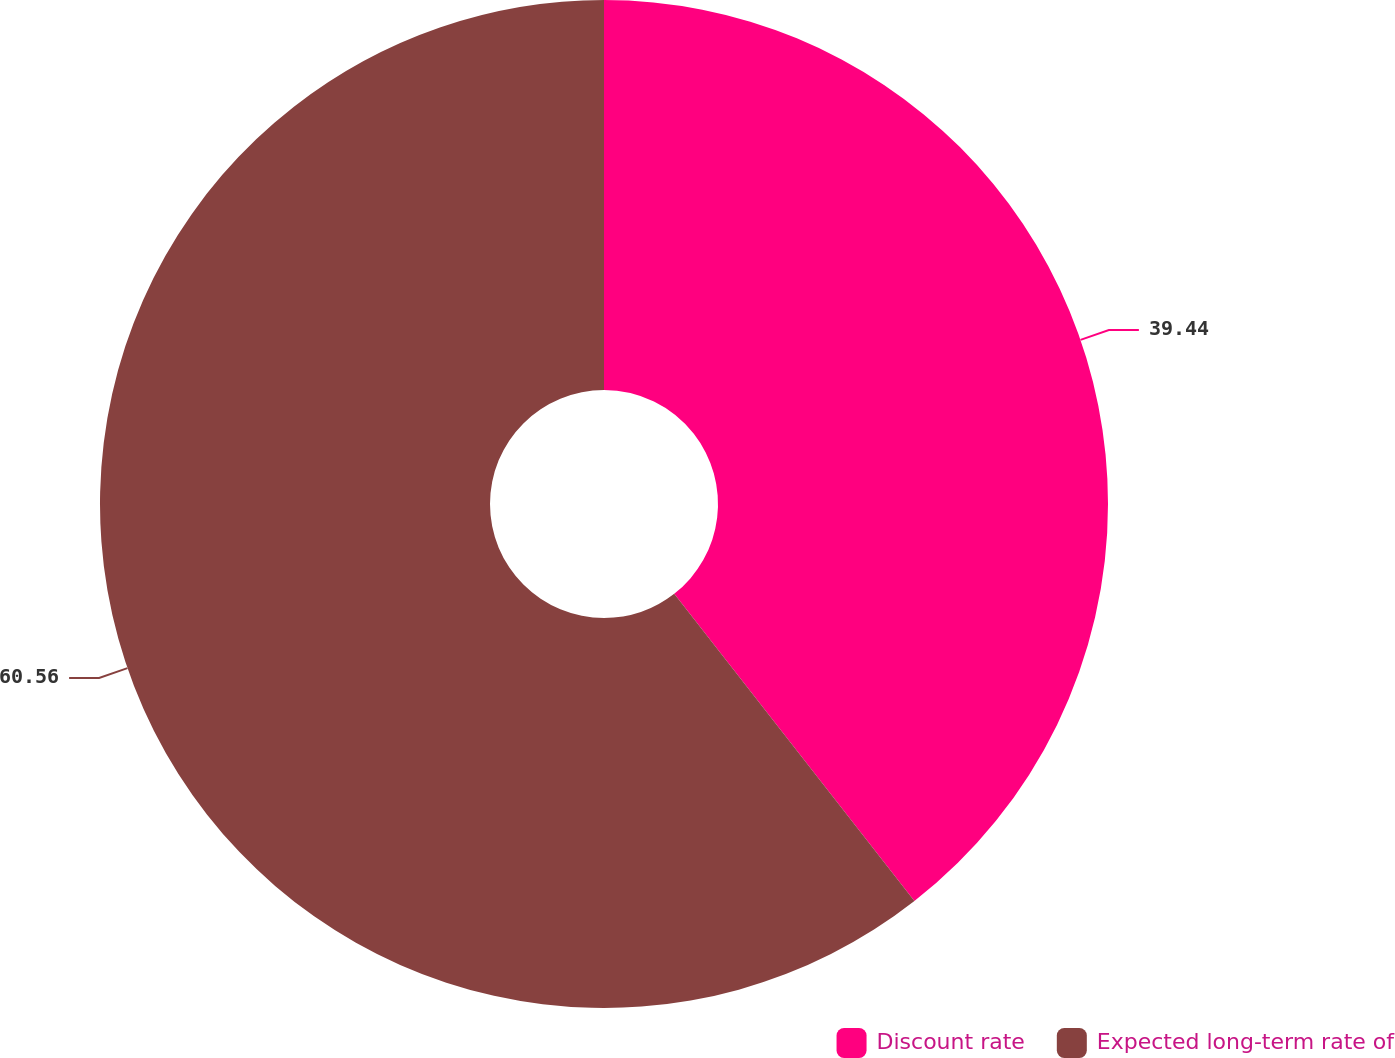Convert chart to OTSL. <chart><loc_0><loc_0><loc_500><loc_500><pie_chart><fcel>Discount rate<fcel>Expected long-term rate of<nl><fcel>39.44%<fcel>60.56%<nl></chart> 